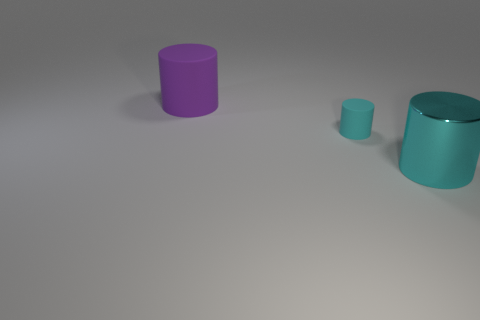Add 2 cylinders. How many objects exist? 5 Subtract all big shiny objects. Subtract all big cyan cylinders. How many objects are left? 1 Add 2 small cyan matte objects. How many small cyan matte objects are left? 3 Add 1 purple rubber cylinders. How many purple rubber cylinders exist? 2 Subtract 0 green cylinders. How many objects are left? 3 